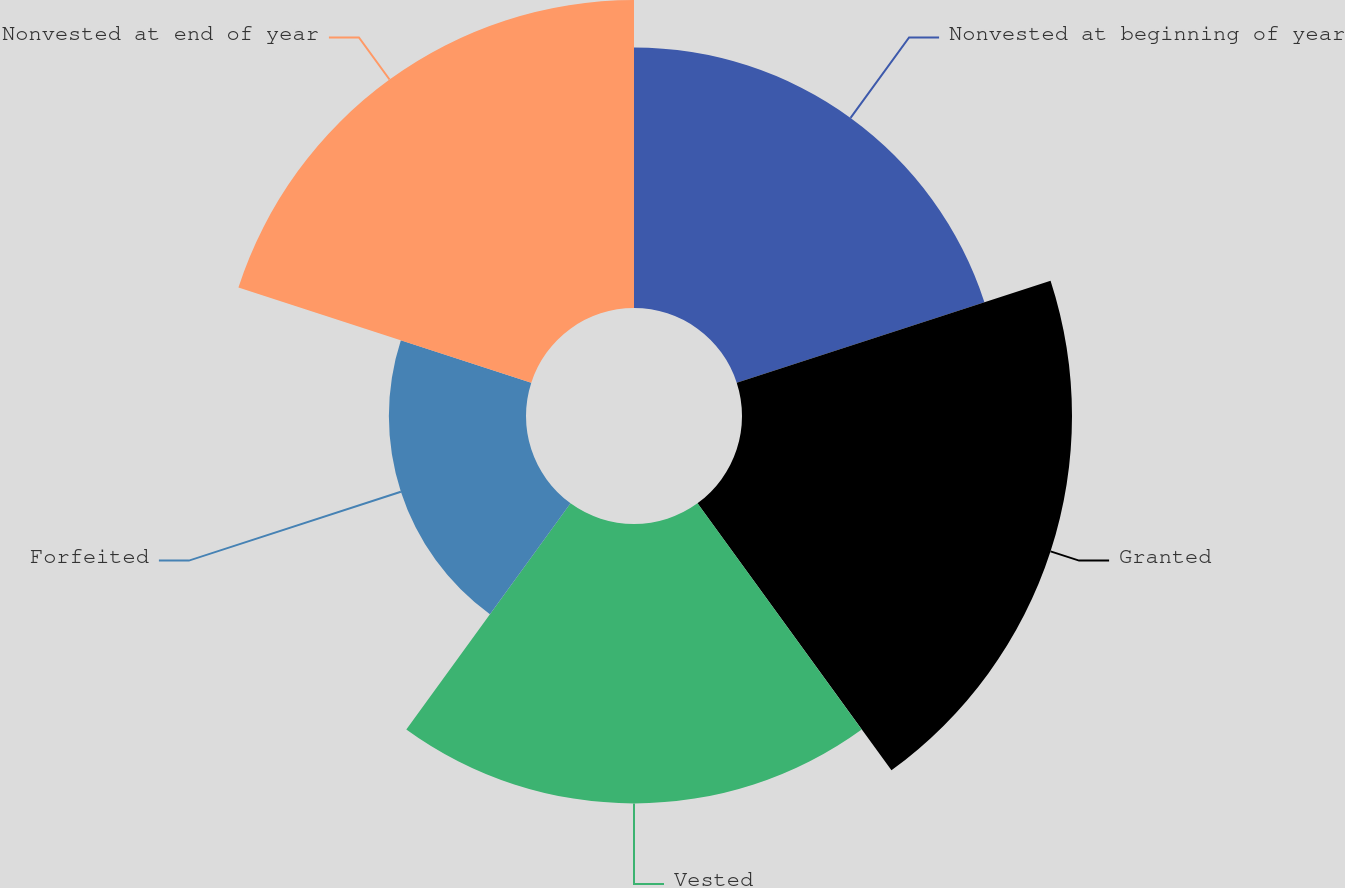<chart> <loc_0><loc_0><loc_500><loc_500><pie_chart><fcel>Nonvested at beginning of year<fcel>Granted<fcel>Vested<fcel>Forfeited<fcel>Nonvested at end of year<nl><fcel>19.81%<fcel>25.1%<fcel>21.25%<fcel>10.43%<fcel>23.42%<nl></chart> 